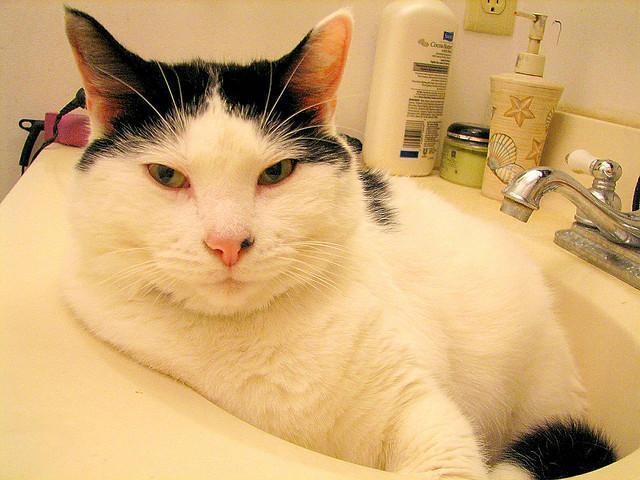How many bottles are there?
Give a very brief answer. 2. 